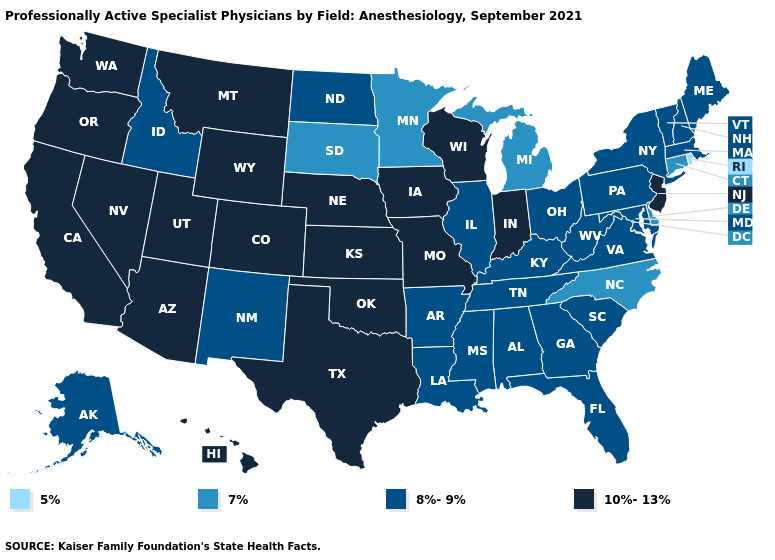Does Missouri have the highest value in the USA?
Short answer required. Yes. Which states have the highest value in the USA?
Quick response, please. Arizona, California, Colorado, Hawaii, Indiana, Iowa, Kansas, Missouri, Montana, Nebraska, Nevada, New Jersey, Oklahoma, Oregon, Texas, Utah, Washington, Wisconsin, Wyoming. Name the states that have a value in the range 8%-9%?
Concise answer only. Alabama, Alaska, Arkansas, Florida, Georgia, Idaho, Illinois, Kentucky, Louisiana, Maine, Maryland, Massachusetts, Mississippi, New Hampshire, New Mexico, New York, North Dakota, Ohio, Pennsylvania, South Carolina, Tennessee, Vermont, Virginia, West Virginia. What is the value of North Dakota?
Answer briefly. 8%-9%. What is the value of Rhode Island?
Keep it brief. 5%. What is the value of Kentucky?
Write a very short answer. 8%-9%. What is the lowest value in states that border Michigan?
Concise answer only. 8%-9%. Name the states that have a value in the range 10%-13%?
Quick response, please. Arizona, California, Colorado, Hawaii, Indiana, Iowa, Kansas, Missouri, Montana, Nebraska, Nevada, New Jersey, Oklahoma, Oregon, Texas, Utah, Washington, Wisconsin, Wyoming. Does the first symbol in the legend represent the smallest category?
Be succinct. Yes. Among the states that border Ohio , which have the lowest value?
Quick response, please. Michigan. Does Arizona have the highest value in the West?
Quick response, please. Yes. Which states have the highest value in the USA?
Short answer required. Arizona, California, Colorado, Hawaii, Indiana, Iowa, Kansas, Missouri, Montana, Nebraska, Nevada, New Jersey, Oklahoma, Oregon, Texas, Utah, Washington, Wisconsin, Wyoming. What is the value of Ohio?
Keep it brief. 8%-9%. Name the states that have a value in the range 7%?
Write a very short answer. Connecticut, Delaware, Michigan, Minnesota, North Carolina, South Dakota. 